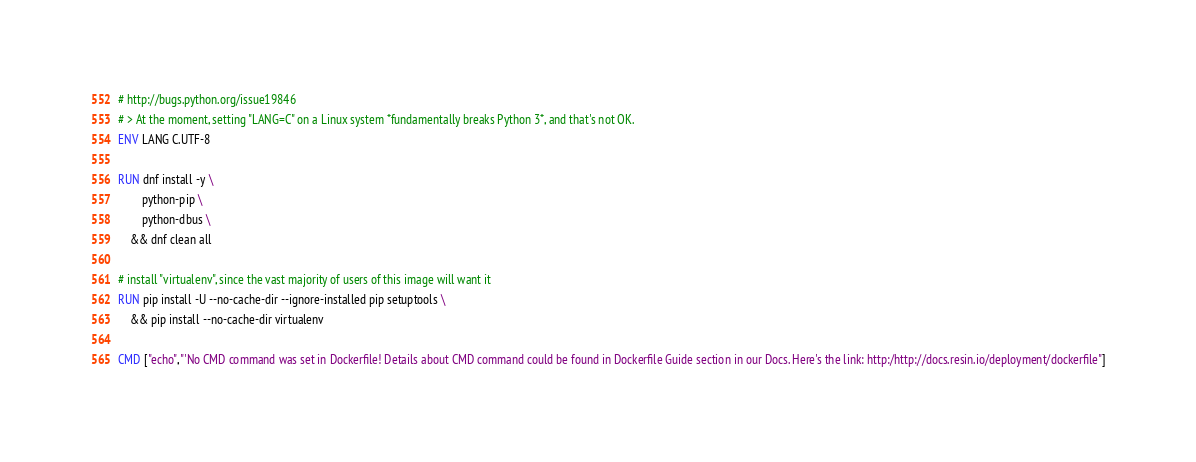Convert code to text. <code><loc_0><loc_0><loc_500><loc_500><_Dockerfile_># http://bugs.python.org/issue19846
# > At the moment, setting "LANG=C" on a Linux system *fundamentally breaks Python 3*, and that's not OK.
ENV LANG C.UTF-8

RUN dnf install -y \
		python-pip \
		python-dbus \
	&& dnf clean all

# install "virtualenv", since the vast majority of users of this image will want it
RUN pip install -U --no-cache-dir --ignore-installed pip setuptools \
	&& pip install --no-cache-dir virtualenv

CMD ["echo","'No CMD command was set in Dockerfile! Details about CMD command could be found in Dockerfile Guide section in our Docs. Here's the link: http:/http://docs.resin.io/deployment/dockerfile"]
</code> 